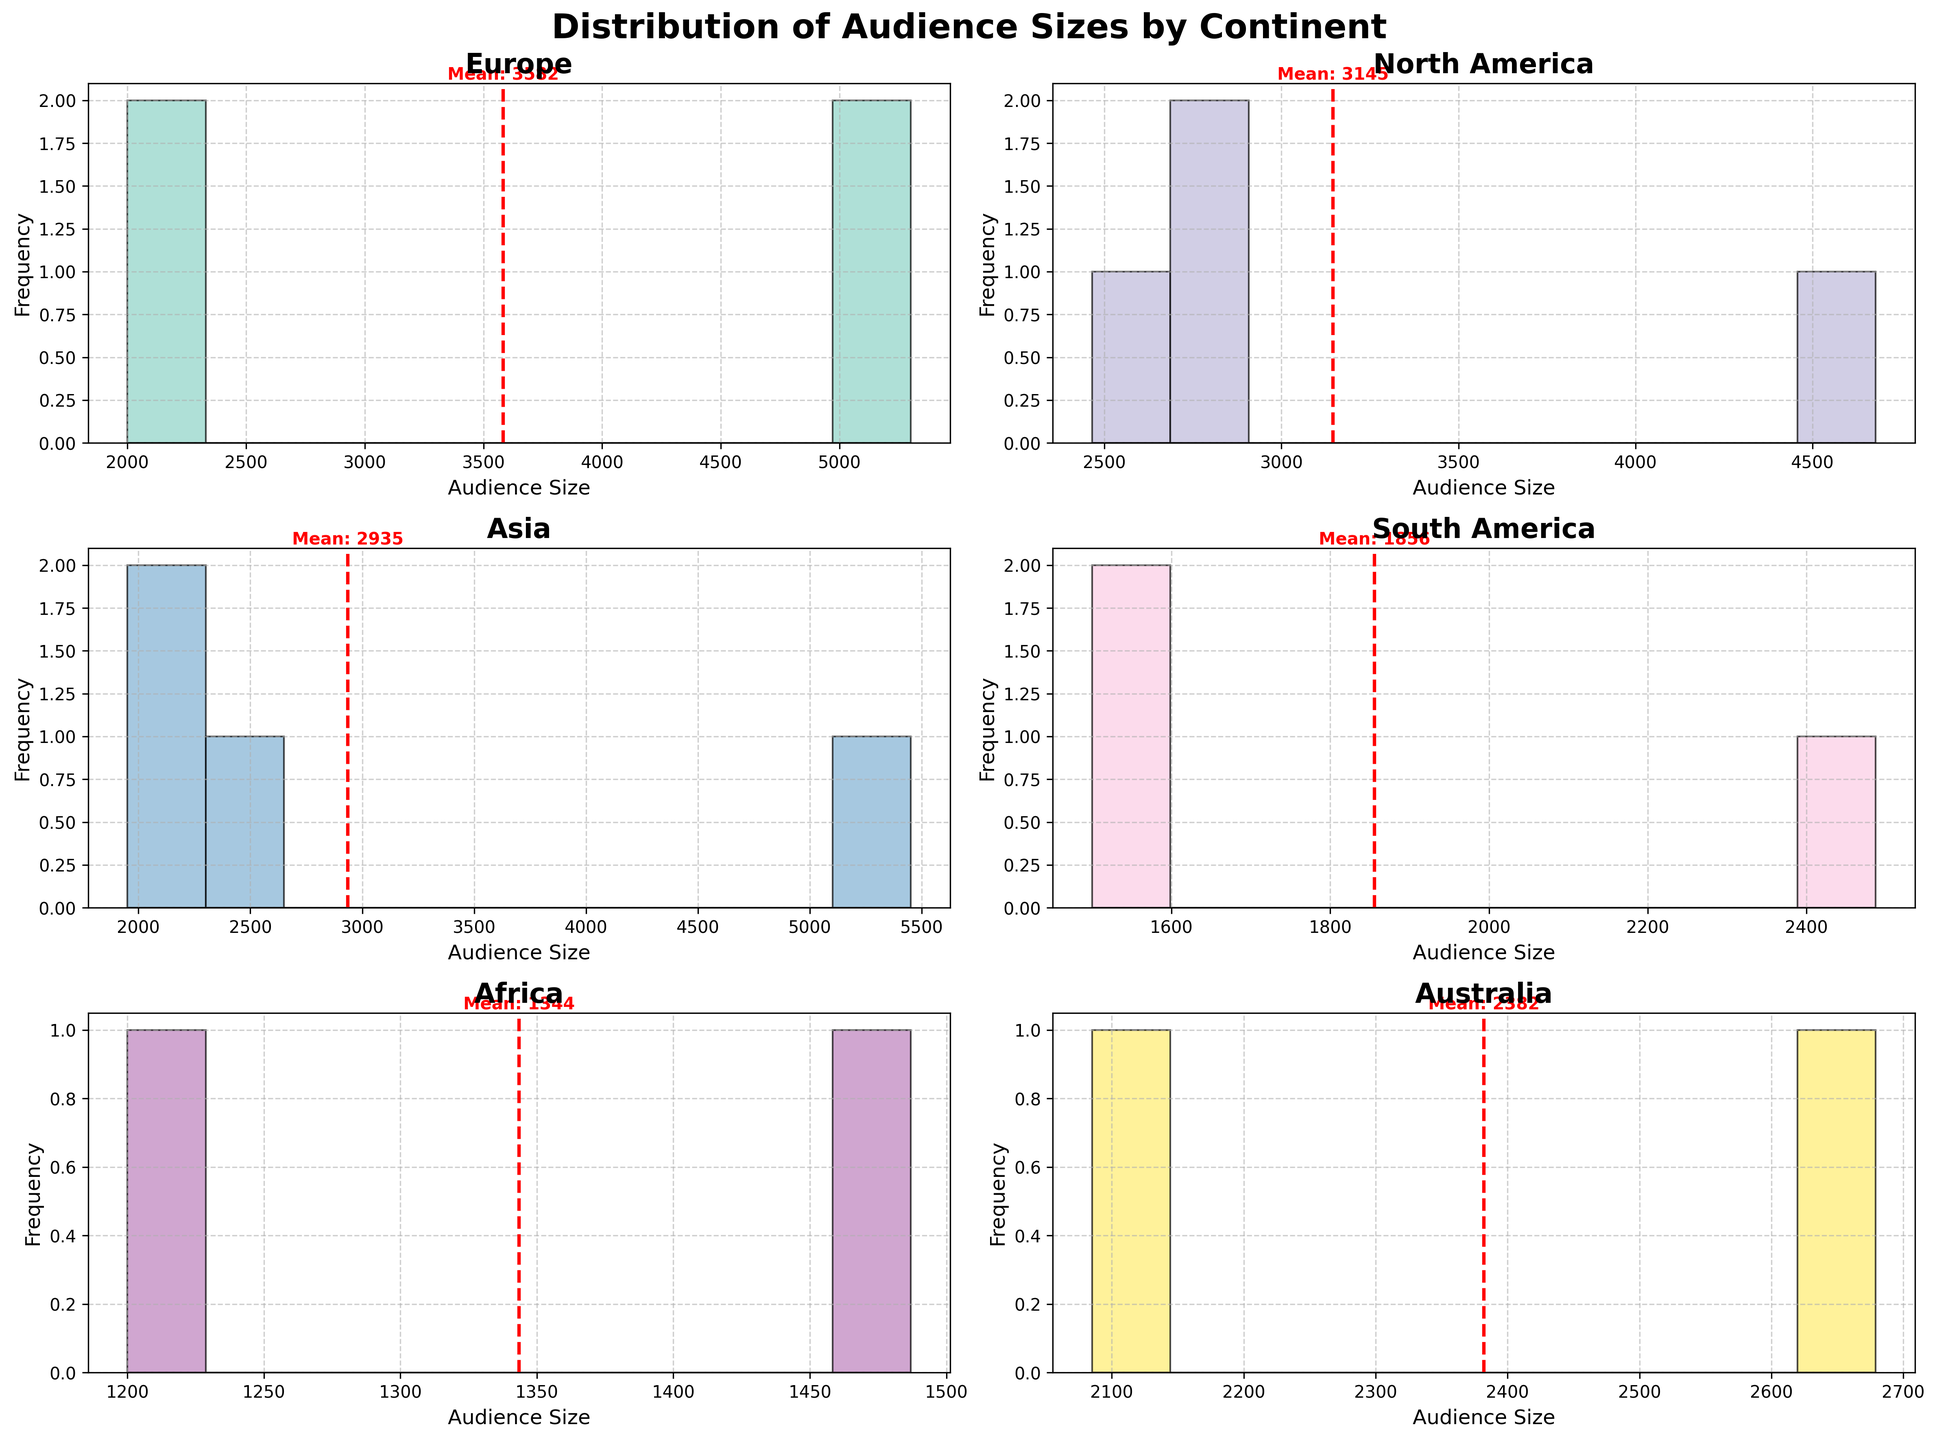Which continent has the highest average audience size? To find the highest average audience size, look at the mean values marked by the red dashed lines in the histograms for each continent. Compare these values and identify the highest one.
Answer: Asia What's the title of the figure? The title is positioned at the top of the figure in large, bold text.
Answer: Distribution of Audience Sizes by Continent Which continent has the smallest venue in terms of audience size? Look for the lowest point on the x-axis for each histogram. Identify which histogram has the smallest value.
Answer: Africa How many continents have a mean audience size above 3000? Look at the red dashed lines showing the mean audience sizes in each histogram. Count how many have a mean value greater than 3000.
Answer: 2 How is the mean audience size indicated in each subplot? In each histogram, the mean is represented by a red dashed line with the numerical mean value written nearby.
Answer: Red dashed line Which continents have their largest bin in the 2000-3000 range? Examine the bin counts on the x-axis for each histogram. Identify the continents where the most frequent bin is in the range of 2000-3000.
Answer: Europe, North America, Australia Which continent has the most evenly spread audience sizes? Check the histograms and see which one has a relatively uniform distribution across all bins, indicating an even spread of audience sizes.
Answer: South America What is the lowest audience size recorded for venues in Europe? Look at the leftmost bin in the Europe histogram to identify the smallest audience size.
Answer: 2000 Which two continents have the closest average audience sizes? Compare the red dashed lines indicating the mean audience sizes and find the two that are closest in value.
Answer: Europe, North America What does the x-axis represent in each subplot? The x-axis represents the audience size values in each histogram.
Answer: Audience Size 